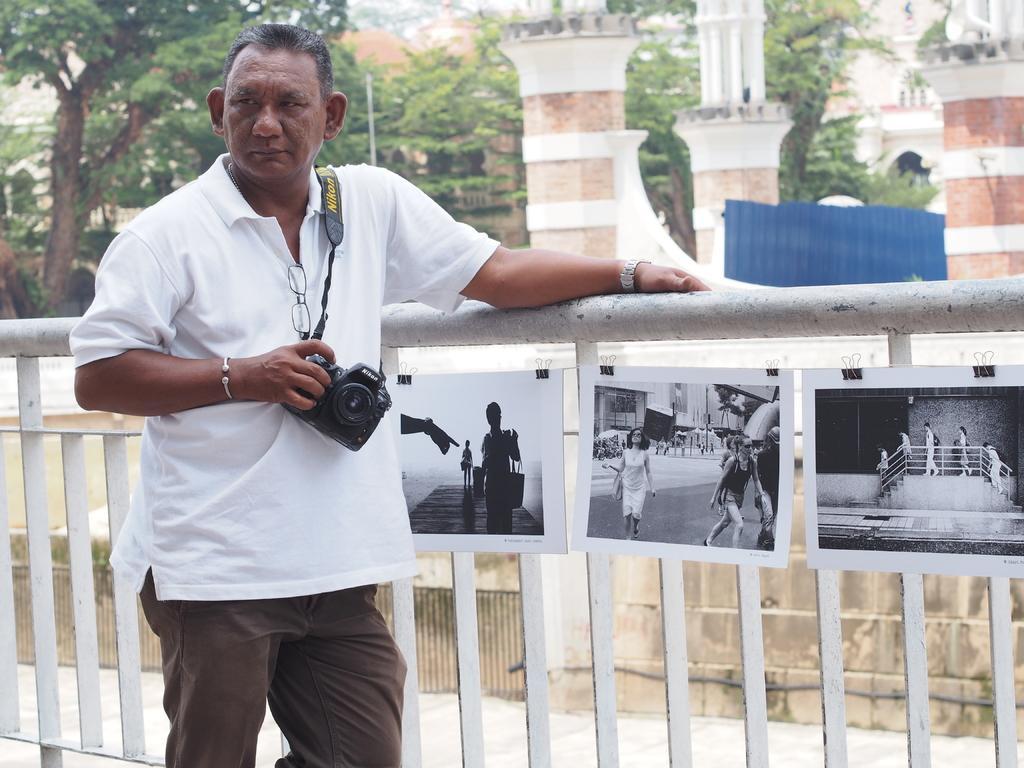In one or two sentences, can you explain what this image depicts? In the picture we can see a man standing near the railing, and he is in white T-shirt and holding a camera and behind the railing we can see some walls and trees and beside it we can see some building. 